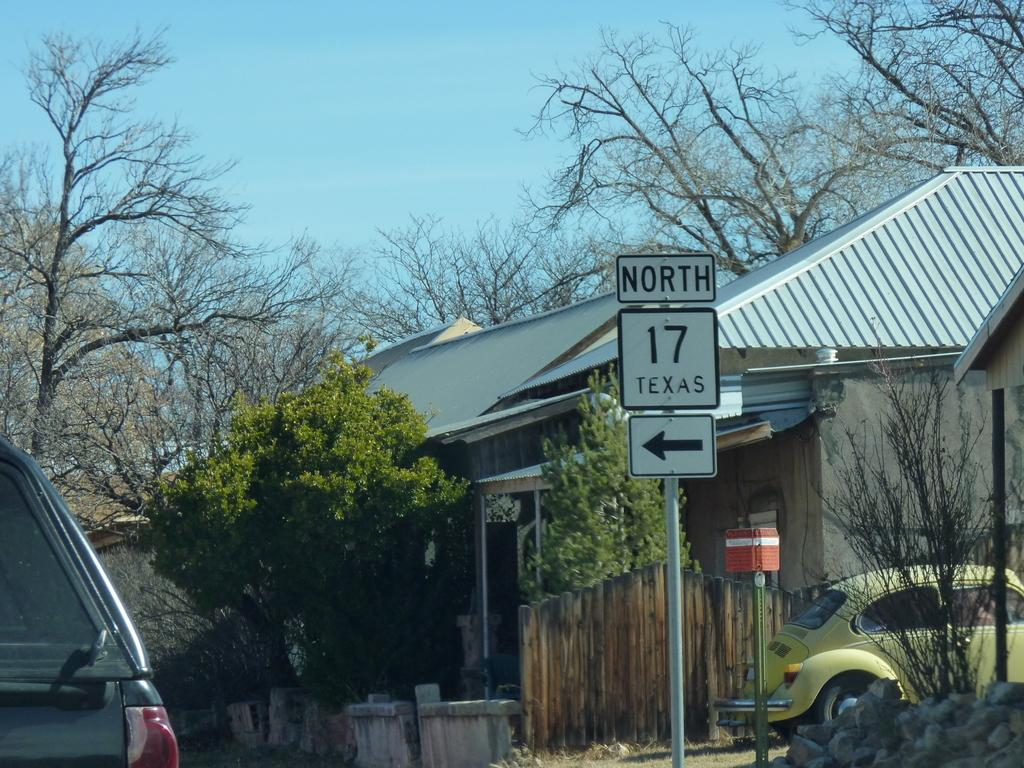What type of structures can be seen in the image? There are houses in the image. What type of vegetation is present in the image? There are trees and plants in the image. What are the vertical objects in the image? There are poles in the image. What type of informational objects are present in the image? There are sign boards in the image. What type of transportation objects are present in the image? There are vehicles in the image. What type of wooden objects can be seen in the image? There are wooden objects in the image. What can be seen in the background of the image? The sky is visible in the background of the image. Where is the crib located in the image? There is no crib present in the image. What type of fruit is hanging from the trees in the image? The image does not show any fruit hanging from the trees; it only shows trees and plants. 